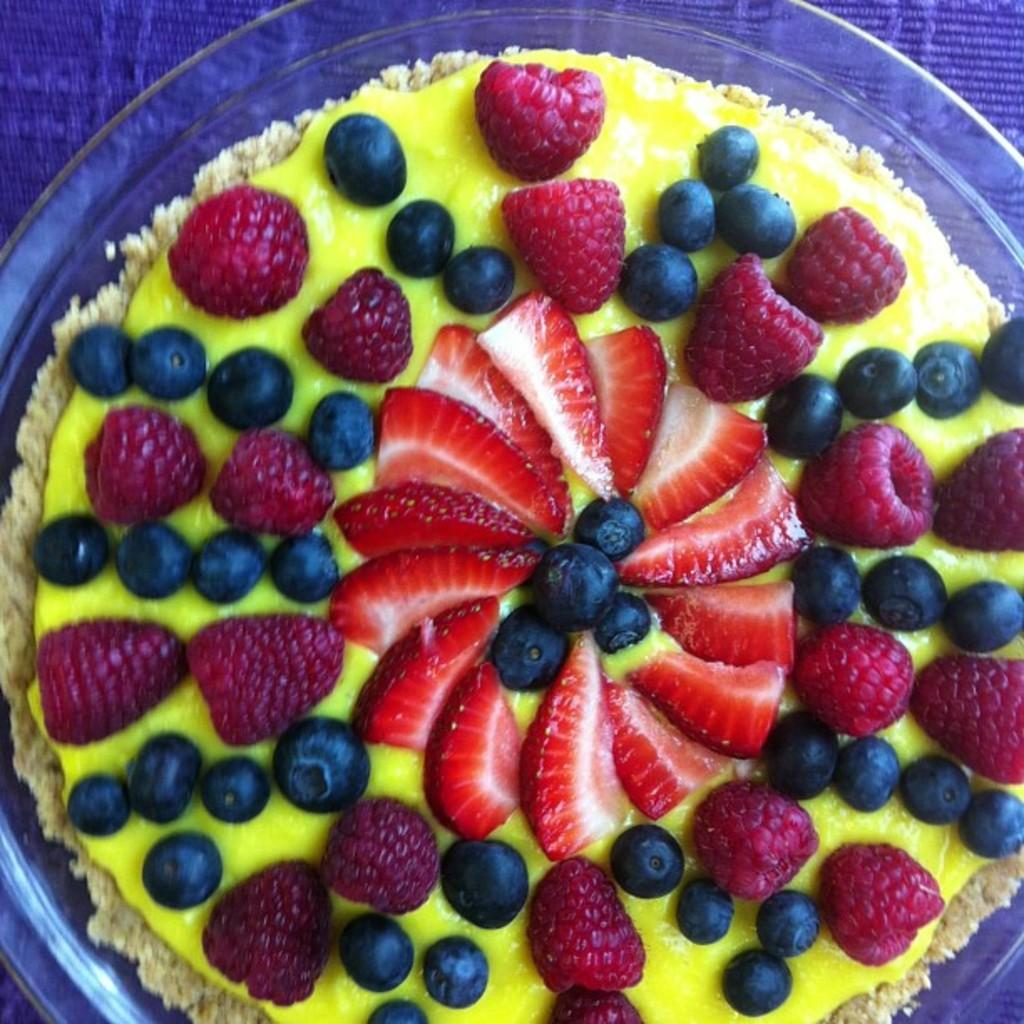What is in the bowl that is visible in the image? There is a bowl of fruit custard in the image. What specific fruits can be found in the fruit custard? The fruit custard contains strawberries, grapes, and raspberries. What type of paste is being used to create the daughter's sandcastle in the image? There is no daughter or sandcastle present in the image; it features a bowl of fruit custard with strawberries, grapes, and raspberries. 